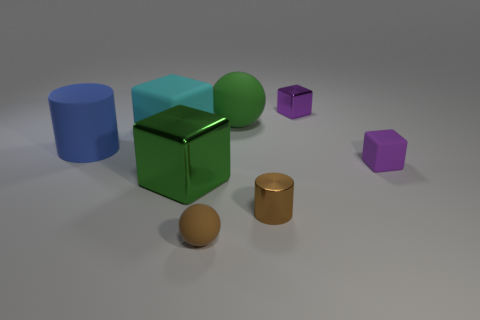Is the metallic cylinder the same color as the tiny ball?
Offer a terse response. Yes. There is a cylinder that is behind the small brown cylinder; is there a sphere in front of it?
Make the answer very short. Yes. There is another metal thing that is the same shape as the purple metal object; what is its color?
Your answer should be very brief. Green. How many objects have the same color as the small cylinder?
Make the answer very short. 1. The tiny rubber object that is in front of the purple cube on the right side of the small purple thing behind the tiny purple matte block is what color?
Make the answer very short. Brown. Do the big sphere and the big green block have the same material?
Provide a succinct answer. No. Does the large cyan matte object have the same shape as the purple shiny object?
Give a very brief answer. Yes. Are there an equal number of brown matte objects that are behind the cyan cube and big green cubes behind the tiny metal block?
Your response must be concise. Yes. What is the color of the other sphere that is the same material as the big ball?
Provide a short and direct response. Brown. What number of other big balls are the same material as the brown sphere?
Keep it short and to the point. 1. 